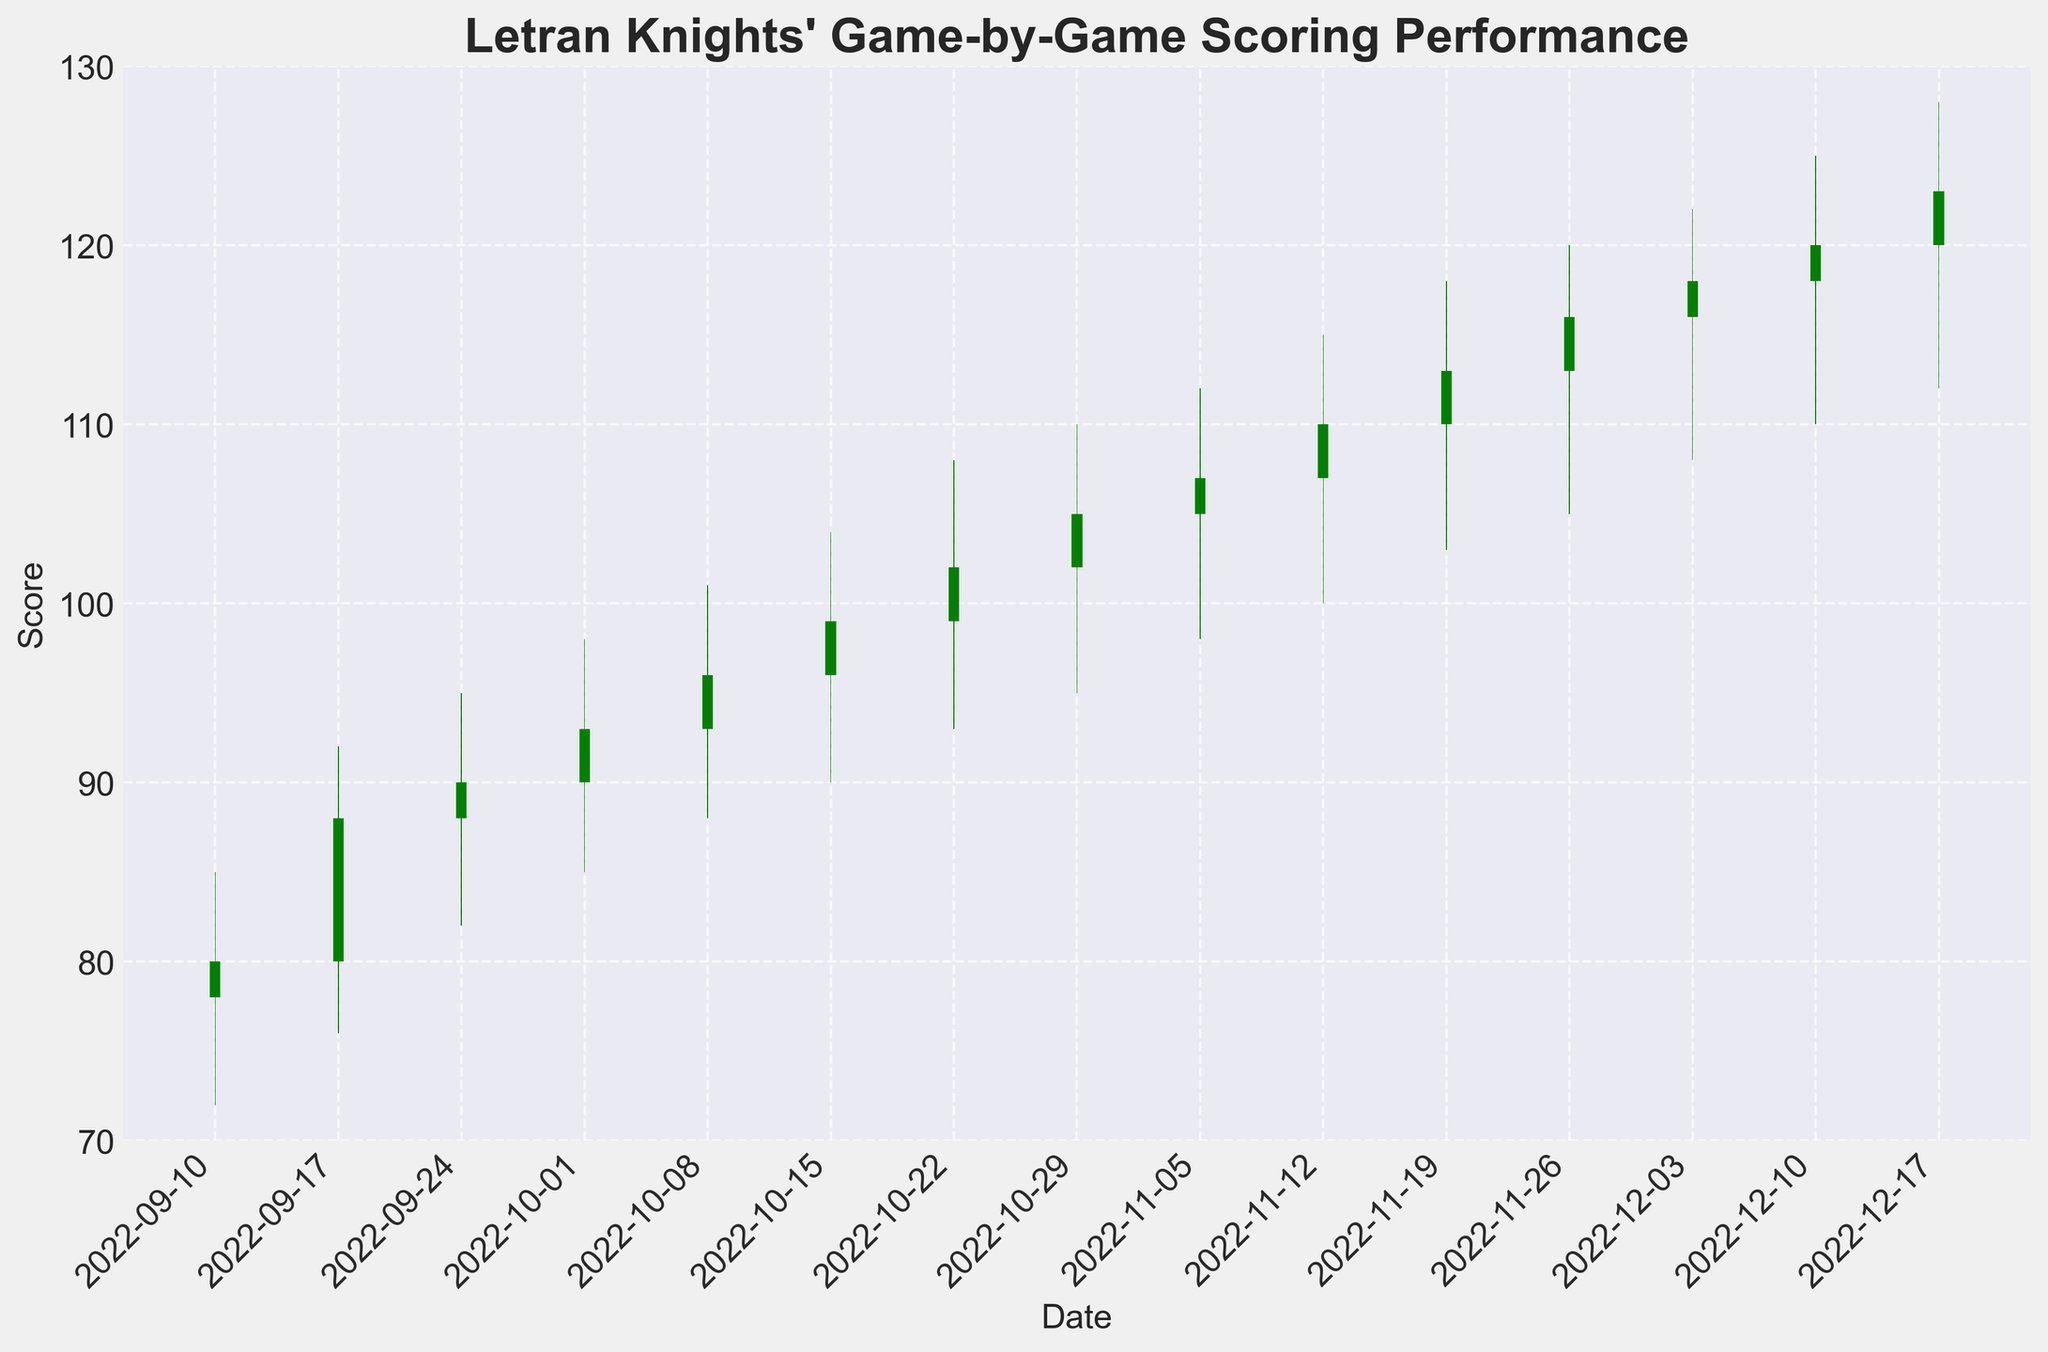what is the title of the figure? The title is usually located at the top of the figure and represents the main subject being depicted. In this case, it is "Letran Knights' Game-by-Game Scoring Performance."
Answer: Letran Knights' Game-by-Game Scoring Performance How many games are covered in the season based on the figure? Each vertical bar represents one game. By counting the number of such bars, we can determine the number of games.
Answer: 15 What was the opening score for the game on November 5th? To find the opening score for November 5th, locate the corresponding bar for that date and find the value at the bottom of the bar.
Answer: 105 On which date did the Letran Knights have their highest 'high' score throughout the season? Identify the tallest bar (highest point) with respect to the 'high' score. Find the corresponding date on the x-axis.
Answer: 2022-12-17 Which date shows a decrease in the score from opening to close? Look for red bars which indicate a decrease in score from the opening to the closing. Then, identify the corresponding date for each red bar.
Answer: None What was the lowest 'low' score of the season and when did it occur? Locate the minimum point among all the bars by looking at the lowest points of the bars. Then find the corresponding date.
Answer: 72 on 2022-09-10 How many games had a higher closing score compared to the opening score? Green bars indicate an increase in score from opening to close. Count the number of green bars.
Answer: 15 What is the average 'opening' score for the first five games of the season? Sum the opening scores for the first five games and divide by 5. (78 + 80 + 88 + 90 + 93) / 5 = 429 / 5
Answer: 85.8 Compare the 'high' scores on September 17th and October 1st. Which one is higher and by how much? Recall the 'high' scores for both dates: September 17th had a 'high' of 92, and October 1st had a 'high' of 98. Subtract to find the difference.
Answer: October 1st is higher by 6 points What trend can you observe in the Letran Knights' closing scores from September to December? Examine the closing scores across the season from September 10th to December 17th. Identify any pattern such as increase, decrease, or fluctuations in the values.
Answer: Generally increasing 